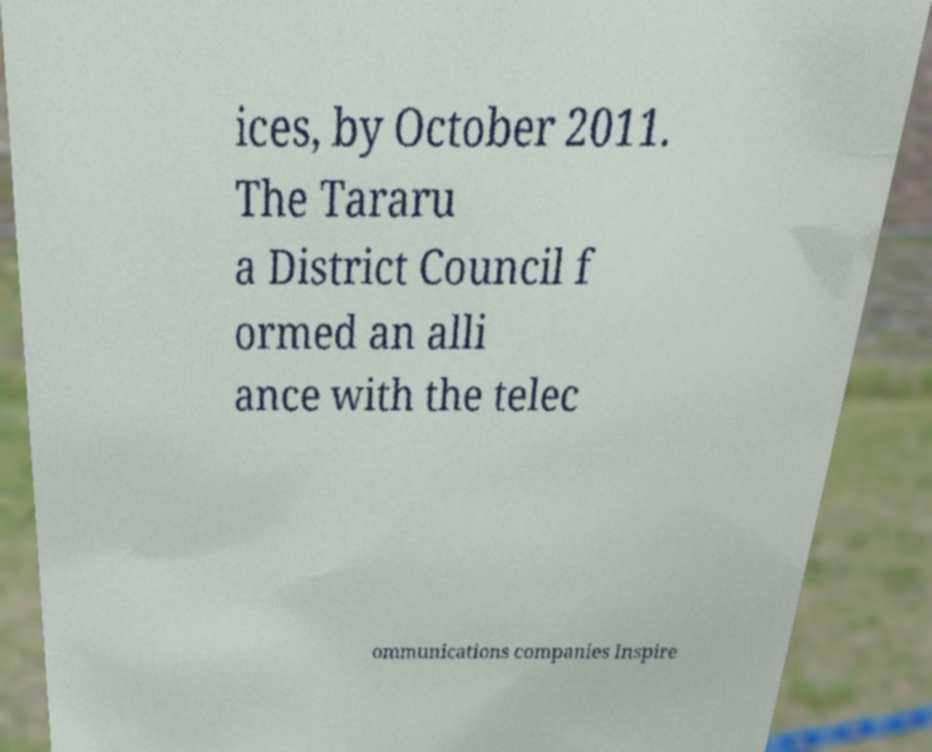Please identify and transcribe the text found in this image. ices, by October 2011. The Tararu a District Council f ormed an alli ance with the telec ommunications companies Inspire 